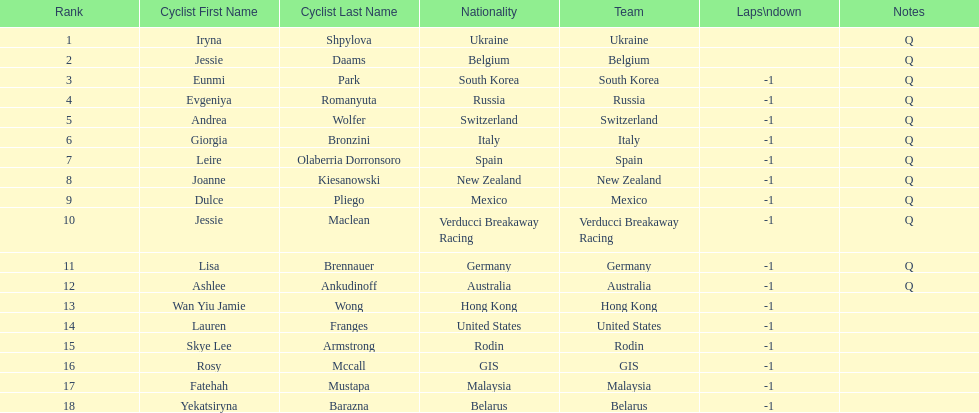Who was the top ranked competitor in this race? Iryna Shpylova. 